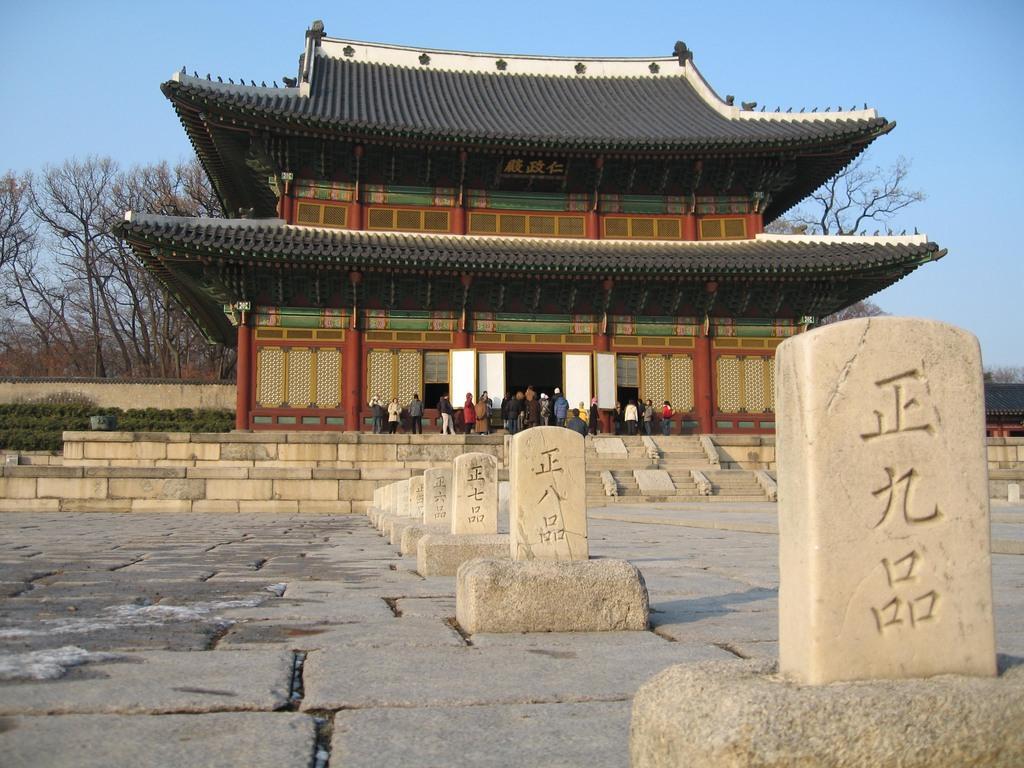Please provide a concise description of this image. This is an outside view. On the right side there are few pillars placed on the rocks. On the pillars there is some text. In the background there is a building. In front of this building there are many people standing and also I can see the stairs. In the background there are many trees. At the top of the image I can see the sky in blue color. 